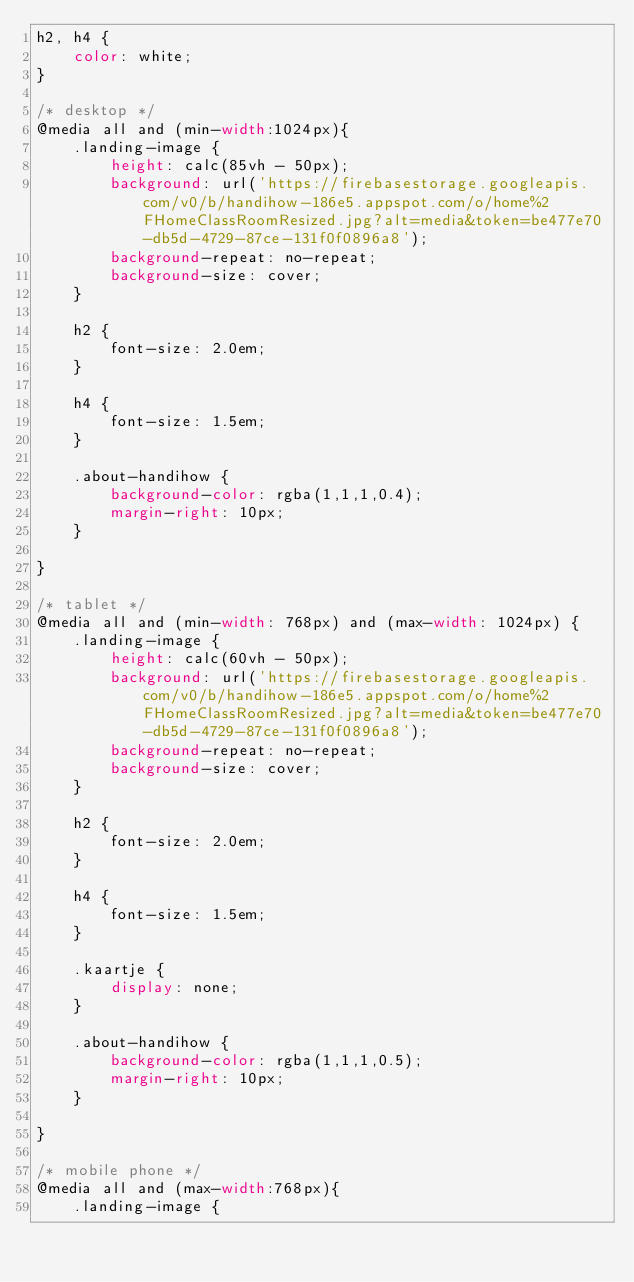<code> <loc_0><loc_0><loc_500><loc_500><_CSS_>h2, h4 {
    color: white;
}

/* desktop */
@media all and (min-width:1024px){
    .landing-image {
        height: calc(85vh - 50px);
        background: url('https://firebasestorage.googleapis.com/v0/b/handihow-186e5.appspot.com/o/home%2FHomeClassRoomResized.jpg?alt=media&token=be477e70-db5d-4729-87ce-131f0f0896a8');
        background-repeat: no-repeat;
        background-size: cover;
    }

    h2 {
        font-size: 2.0em;
    }

    h4 {
        font-size: 1.5em;
    }

    .about-handihow {
        background-color: rgba(1,1,1,0.4);
        margin-right: 10px;
    }

}

/* tablet */
@media all and (min-width: 768px) and (max-width: 1024px) {
    .landing-image {
        height: calc(60vh - 50px);
        background: url('https://firebasestorage.googleapis.com/v0/b/handihow-186e5.appspot.com/o/home%2FHomeClassRoomResized.jpg?alt=media&token=be477e70-db5d-4729-87ce-131f0f0896a8');
        background-repeat: no-repeat;
        background-size: cover;
    }

    h2 {
        font-size: 2.0em;
    }

    h4 {
        font-size: 1.5em;
    }

    .kaartje {
        display: none;
    }

    .about-handihow {
        background-color: rgba(1,1,1,0.5);
        margin-right: 10px;
    }

}

/* mobile phone */
@media all and (max-width:768px){
    .landing-image {</code> 